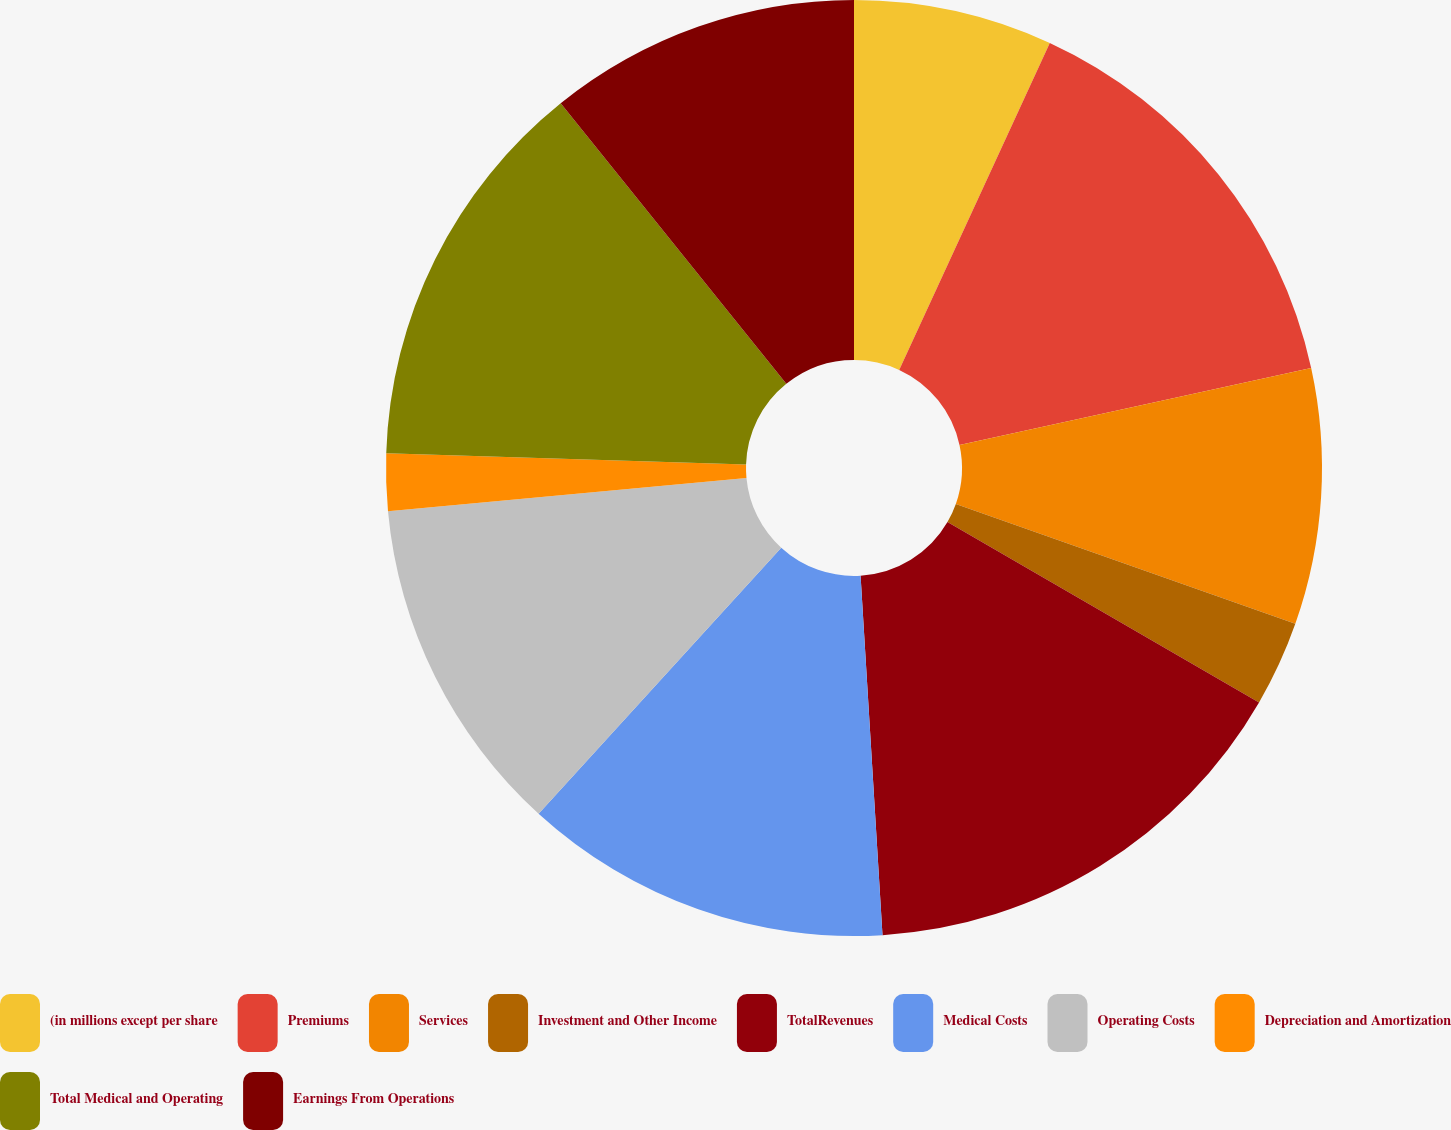<chart> <loc_0><loc_0><loc_500><loc_500><pie_chart><fcel>(in millions except per share<fcel>Premiums<fcel>Services<fcel>Investment and Other Income<fcel>TotalRevenues<fcel>Medical Costs<fcel>Operating Costs<fcel>Depreciation and Amortization<fcel>Total Medical and Operating<fcel>Earnings From Operations<nl><fcel>6.87%<fcel>14.7%<fcel>8.83%<fcel>2.95%<fcel>15.68%<fcel>12.74%<fcel>11.76%<fcel>1.97%<fcel>13.72%<fcel>10.78%<nl></chart> 